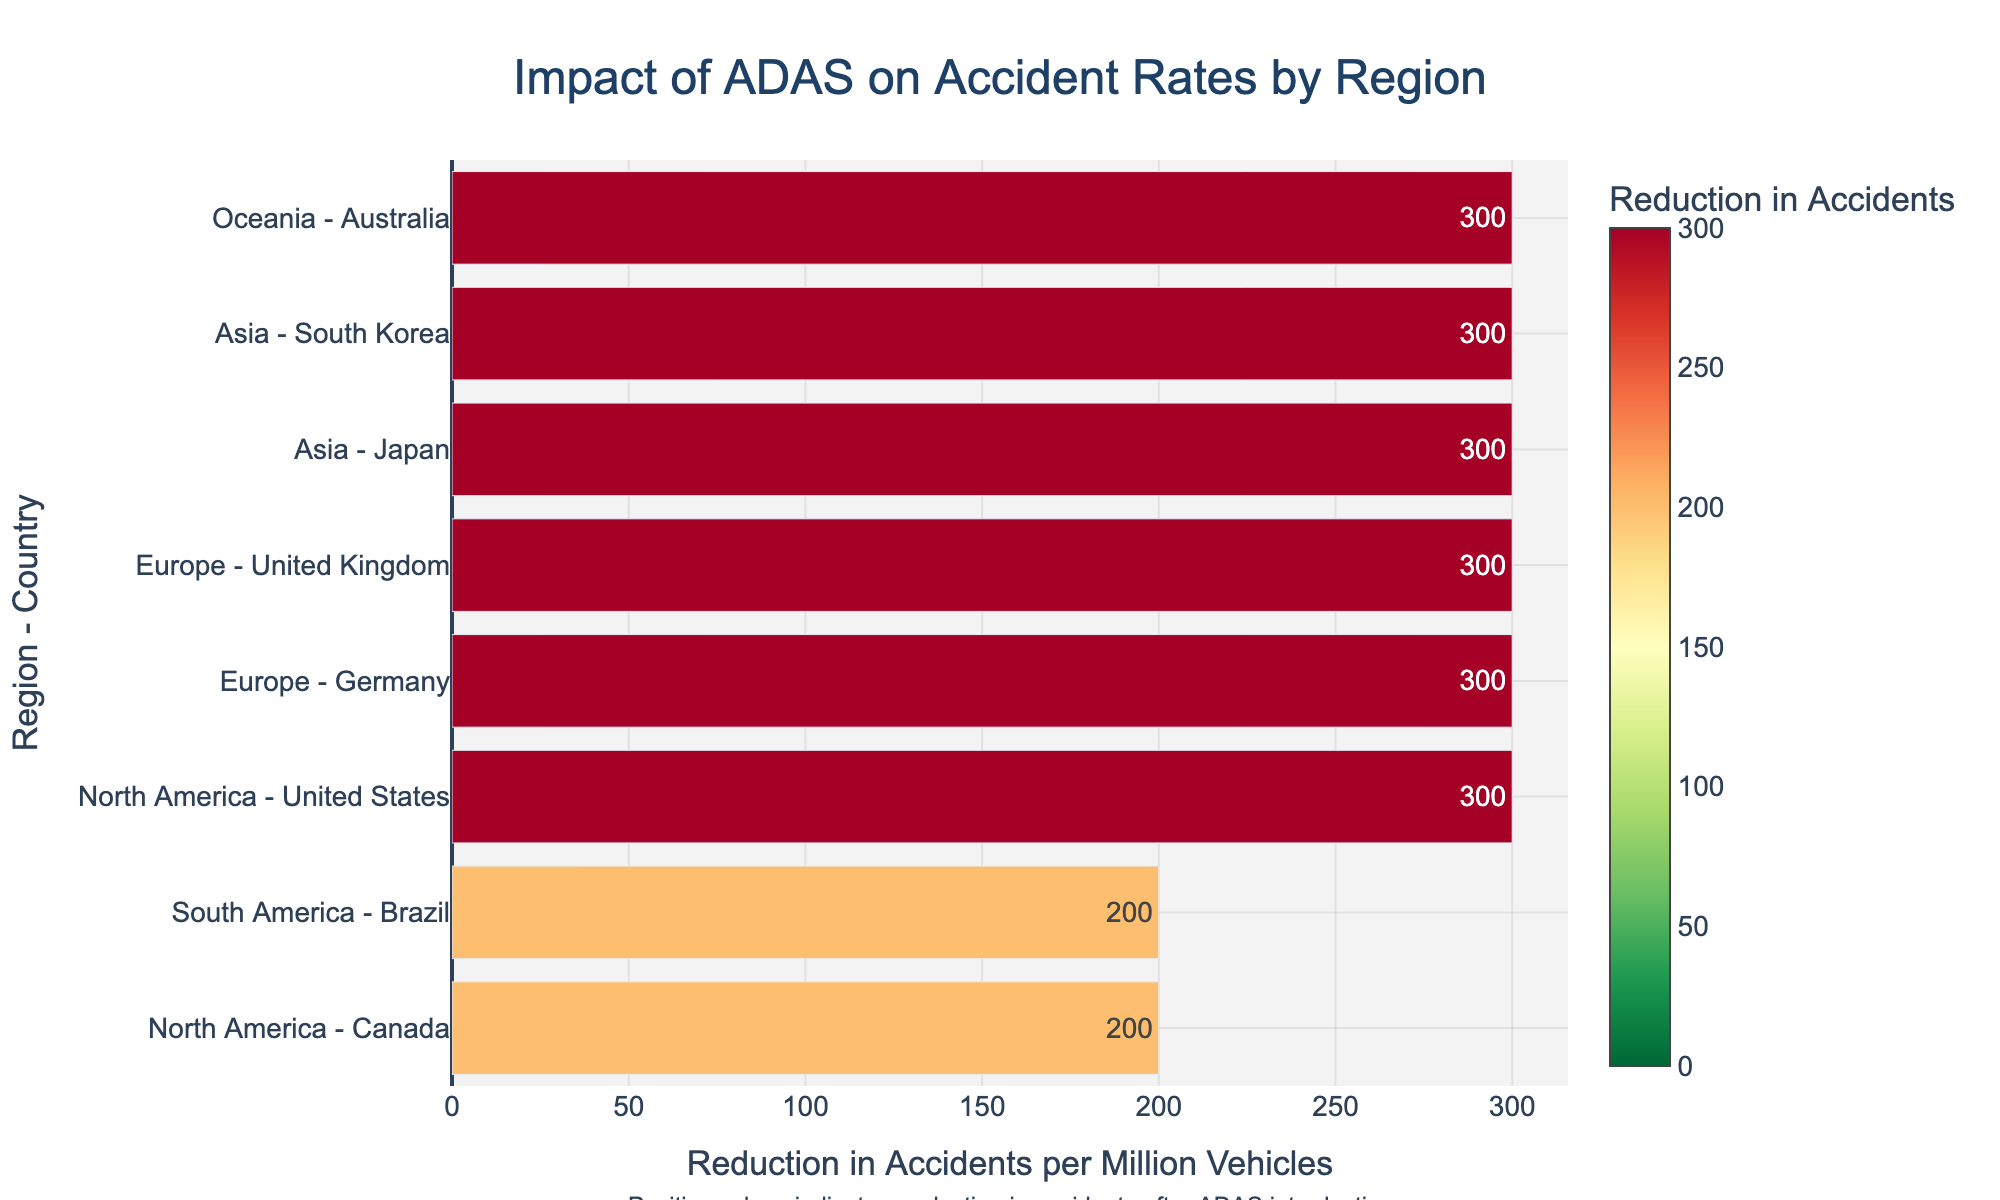Which country saw the largest reduction in accident rates after the introduction of ADAS? Look at the data points and identify the country with the longest bar extending to the right, indicating the greatest reduction. The United States has the largest reduction with a difference of 300 accidents per million vehicles.
Answer: United States Which region experienced the smallest reduction in accident rates? Look at the data points and identify the shortest bar extending to the right. Canada in North America has the smallest reduction with a difference of 200 accidents per million vehicles.
Answer: North America (Canada) How does the reduction in accident rates in Germany compare to Japan? Compare the bars for Germany and Japan. Germany’s bar shows a reduction of 300 accidents per million vehicles, while Japan’s bar shows a reduction of 300 accidents per million vehicles as well.
Answer: Equal What's the average reduction in accident rates for North American countries? Identify the bars for North America (United States and Canada) and calculate the average of their reductions. The reductions are 300 and 200 respectively, so the average is (300 + 200)/2 = 250.
Answer: 250 Which country in Europe saw a greater reduction in accident rates? Compare the bars for Germany and United Kingdom. Germany has a reduction of 300, while the United Kingdom has a reduction of 300.
Answer: Equal What is the total reduction in accident rates for Asian countries? Add the reductions for Japan and South Korea. Japan has a reduction of 300 and South Korea has a reduction of 300, so the total is 300 + 300 = 600.
Answer: 600 Which region has the most consistent reductions in accident rates across its countries? Look at the lengths of the bars within each region and determine the region with the least variation. Europe (Germany and United Kingdom both have reductions of 300 each).
Answer: Europe How many countries exhibit reductions of 300 accidents per million vehicles? Count the bars with a reduction of exactly 300. United States, Germany, United Kingdom, Japan, and South Korea each have a reduction of 300 accidents per million vehicles.
Answer: 5 Which country in South America is on the plot and what is its reduction? Identify the bar for South America and read the reduction value. Brazil has a reduction of 200 accidents per million vehicles.
Answer: Brazil, 200 